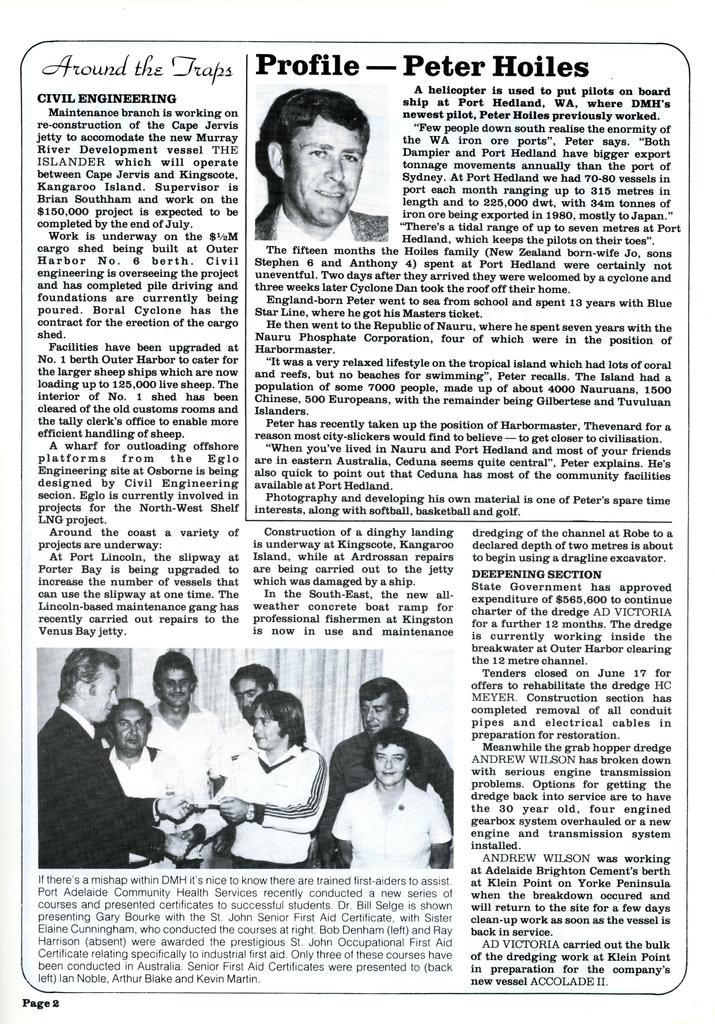What is present on the paper in the image? The paper contains text and human images. Can you describe the text on the paper? Unfortunately, the specific content of the text cannot be determined from the image. What additional information is visible on the paper? There is a page number visible at the bottom of the paper. How many legs are visible on the human images in the image? There are no legs visible in the image, as the human images are not detailed enough to show individual body parts. 